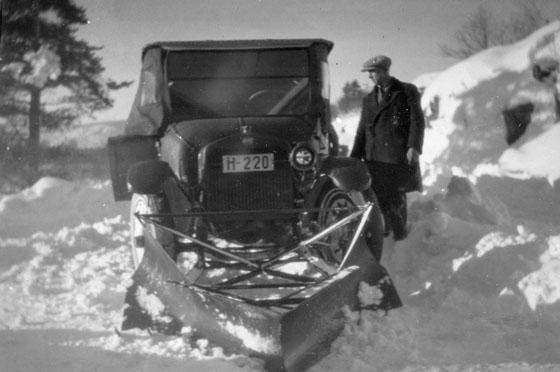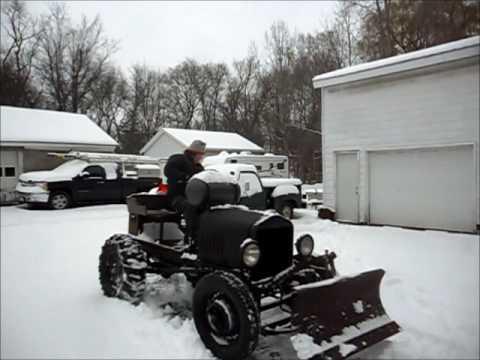The first image is the image on the left, the second image is the image on the right. For the images displayed, is the sentence "Both images in the pair are in black and white." factually correct? Answer yes or no. No. The first image is the image on the left, the second image is the image on the right. Analyze the images presented: Is the assertion "In at least one image there is a single motorized snow plow going left." valid? Answer yes or no. No. 